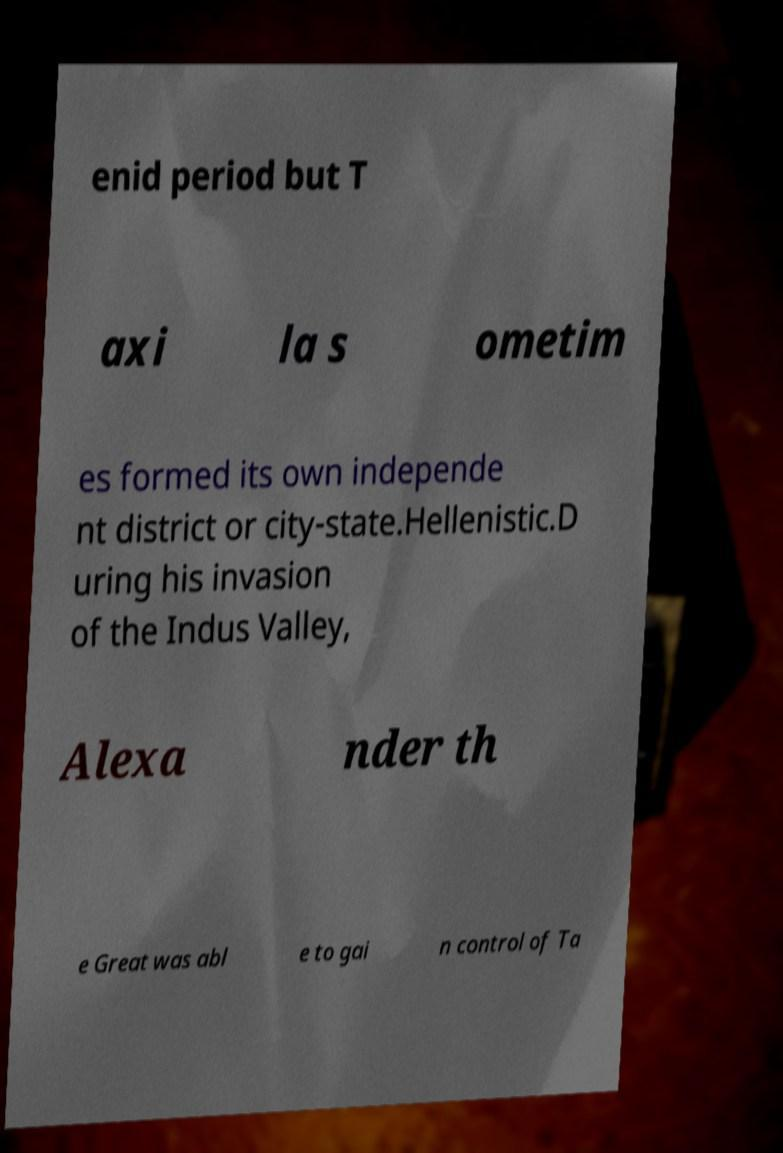Please read and relay the text visible in this image. What does it say? enid period but T axi la s ometim es formed its own independe nt district or city-state.Hellenistic.D uring his invasion of the Indus Valley, Alexa nder th e Great was abl e to gai n control of Ta 